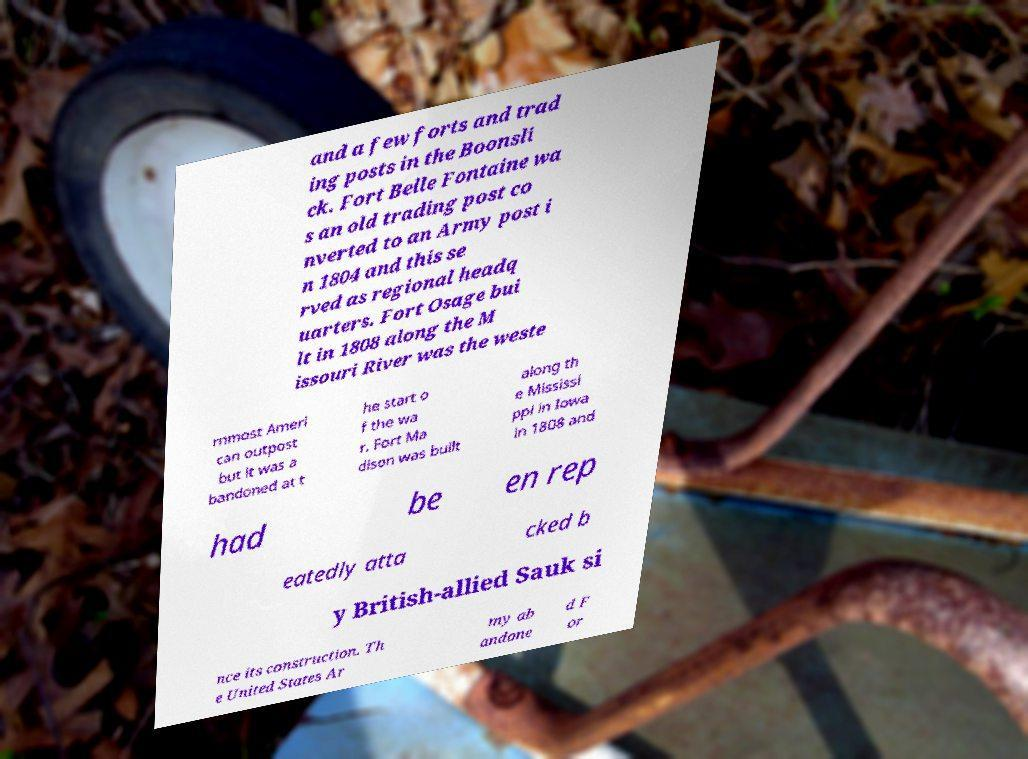There's text embedded in this image that I need extracted. Can you transcribe it verbatim? and a few forts and trad ing posts in the Boonsli ck. Fort Belle Fontaine wa s an old trading post co nverted to an Army post i n 1804 and this se rved as regional headq uarters. Fort Osage bui lt in 1808 along the M issouri River was the weste rnmost Ameri can outpost but it was a bandoned at t he start o f the wa r. Fort Ma dison was built along th e Mississi ppi in Iowa in 1808 and had be en rep eatedly atta cked b y British-allied Sauk si nce its construction. Th e United States Ar my ab andone d F or 